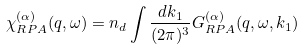Convert formula to latex. <formula><loc_0><loc_0><loc_500><loc_500>\chi _ { R P A } ^ { ( \alpha ) } ( { q } , \omega ) = n _ { d } \int \frac { d { k } _ { 1 } } { ( 2 \pi ) ^ { 3 } } G ^ { ( \alpha ) } _ { R P A } ( { q } , \omega , { k } _ { 1 } )</formula> 